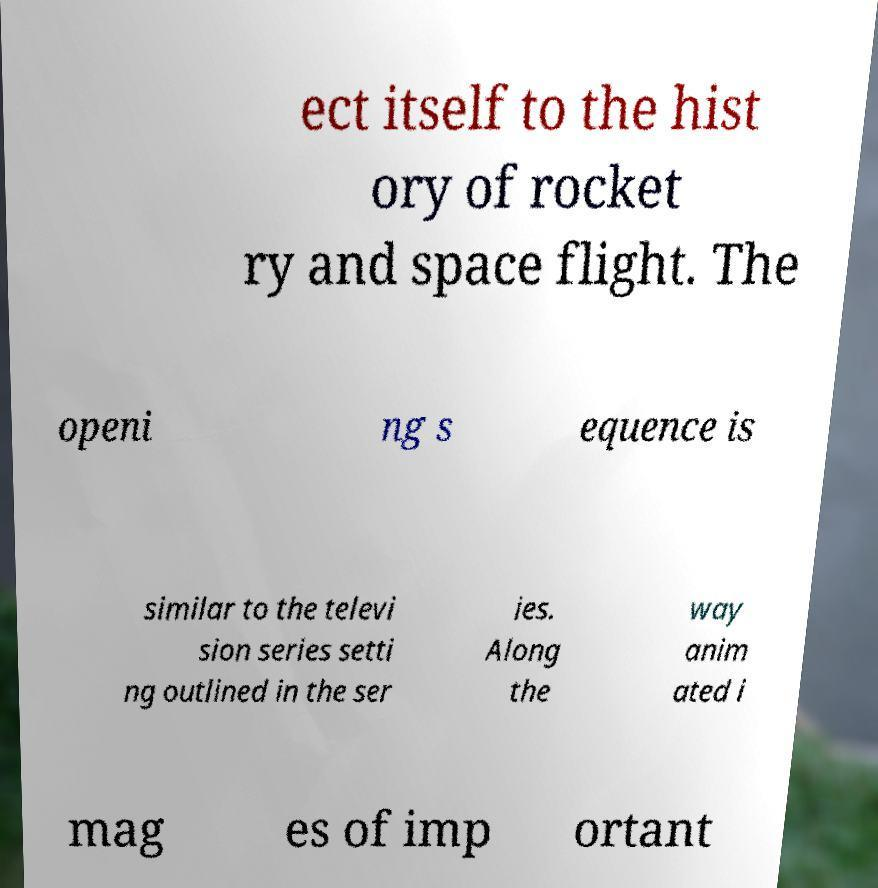Please read and relay the text visible in this image. What does it say? ect itself to the hist ory of rocket ry and space flight. The openi ng s equence is similar to the televi sion series setti ng outlined in the ser ies. Along the way anim ated i mag es of imp ortant 